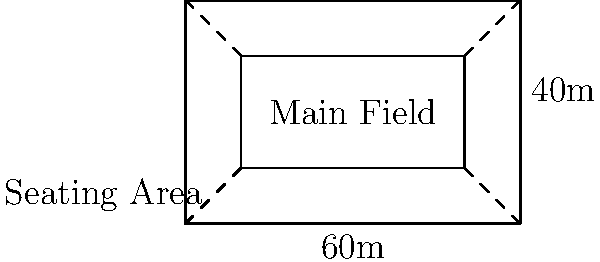At Moycullen's home stadium, the seating area surrounds the main field as shown in the diagram. The outer rectangle represents the total stadium area, while the inner rectangle is the main field. If the stadium is 60m long and 40m wide, and the seating area has a uniform width of 10m on all sides, calculate the total seating area in square meters. Let's approach this step-by-step:

1) First, we need to calculate the area of the entire stadium:
   Stadium Area = Length × Width
   $A_{stadium} = 60m \times 40m = 2400m^2$

2) Next, we calculate the area of the main field:
   Field Length = Stadium Length - (2 × Seating Width)
   $L_{field} = 60m - (2 \times 10m) = 40m$
   
   Field Width = Stadium Width - (2 × Seating Width)
   $W_{field} = 40m - (2 \times 10m) = 20m$
   
   Field Area = Field Length × Field Width
   $A_{field} = 40m \times 20m = 800m^2$

3) The seating area is the difference between the stadium area and the field area:
   Seating Area = Stadium Area - Field Area
   $A_{seating} = A_{stadium} - A_{field}$
   $A_{seating} = 2400m^2 - 800m^2 = 1600m^2$

Therefore, the total seating area is 1600 square meters.
Answer: 1600 $m^2$ 